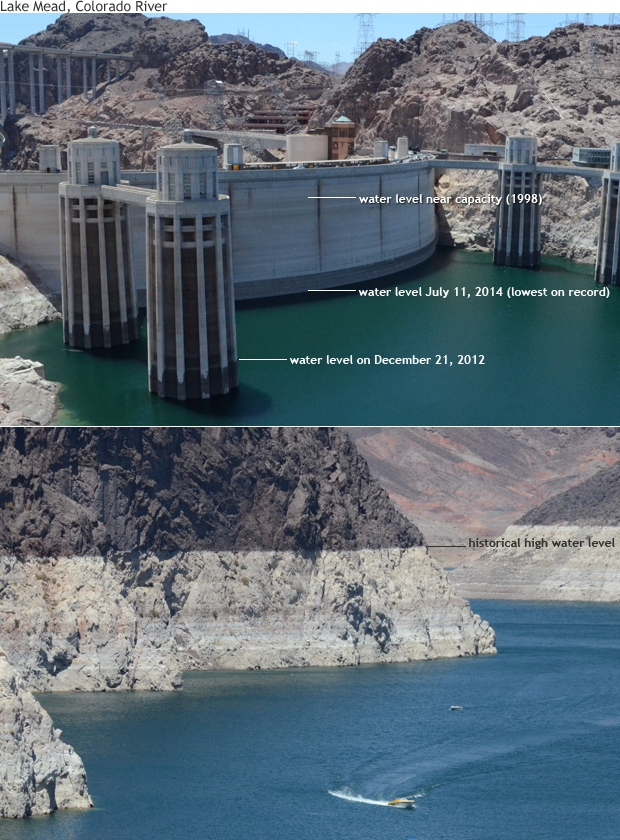What does the 'bathtub ring' around the lake indicate about the water levels over time? The 'bathtub ring' around Lake Mead, visible in the image as a broad band of lighter-colored rock, shows where the lake's water level used to be. This prominent mark indicates how much the water level has fallen over the years. The ring forms due to mineral deposits left by the water, creating a distinct line on the rock as the water recedes. This dramatic drop reveals the strain on water resources and points to issues like prolonged drought, increased water usage, and climate change. The stark difference in color between the submerged and exposed rock areas tells a story of an evolving and increasingly strained ecosystem. 